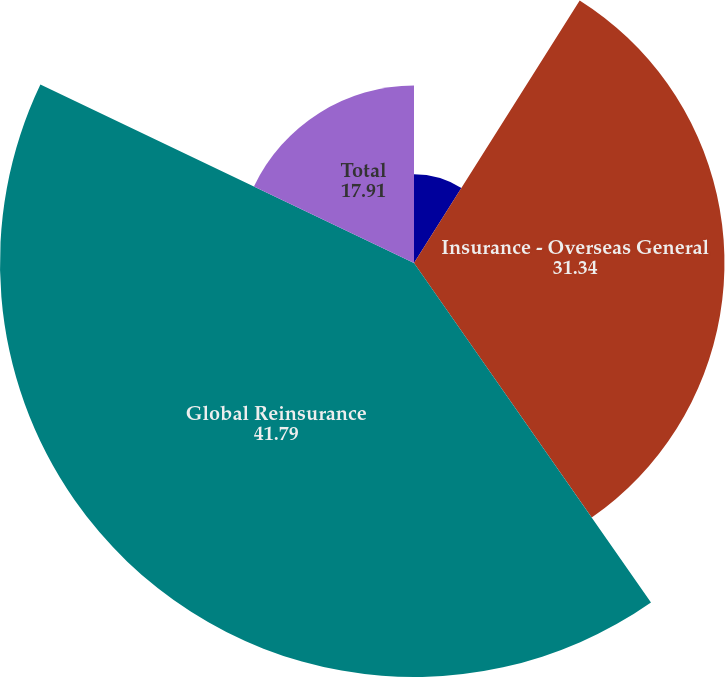Convert chart. <chart><loc_0><loc_0><loc_500><loc_500><pie_chart><fcel>Insurance - North American<fcel>Insurance - Overseas General<fcel>Global Reinsurance<fcel>Total<nl><fcel>8.96%<fcel>31.34%<fcel>41.79%<fcel>17.91%<nl></chart> 